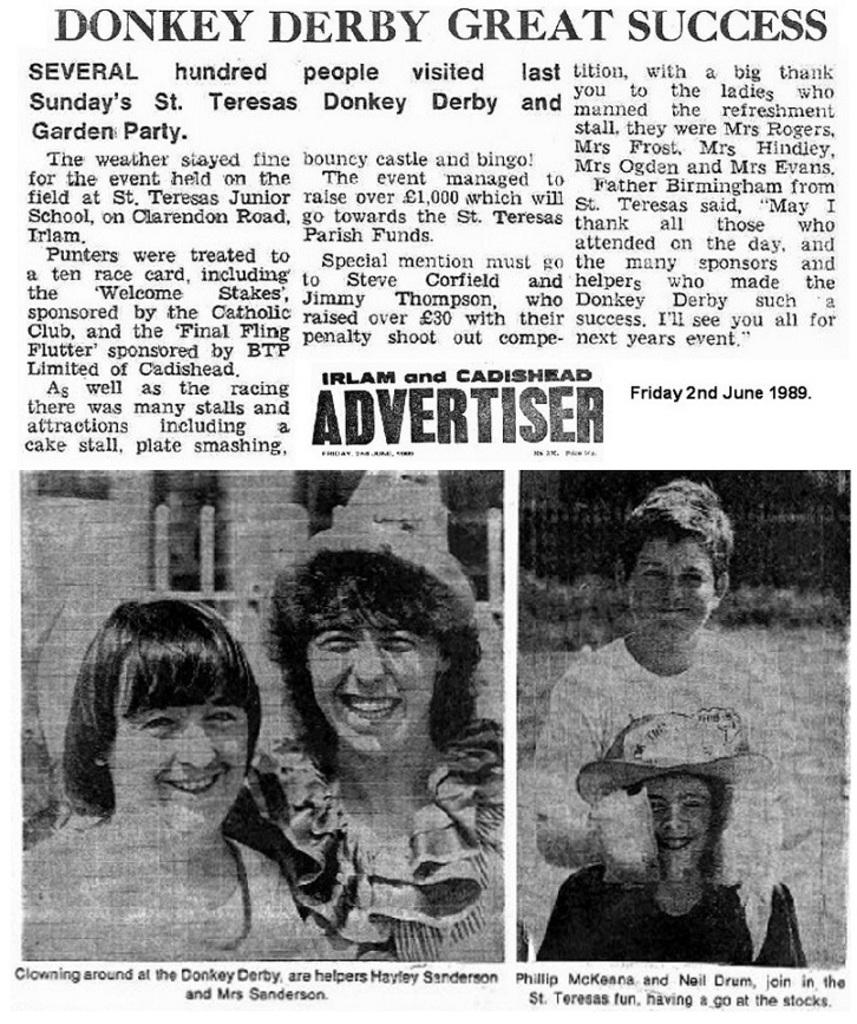What is the main object in the image? There is an article of a newspaper in the image. What can be found within the newspaper article? There is text in the newspaper article. Are there any visual elements in the newspaper article? Yes, there are two images in the newspaper article. How many houses are depicted in the newspaper article? There is no information about houses in the newspaper article; it only contains text and two images. 